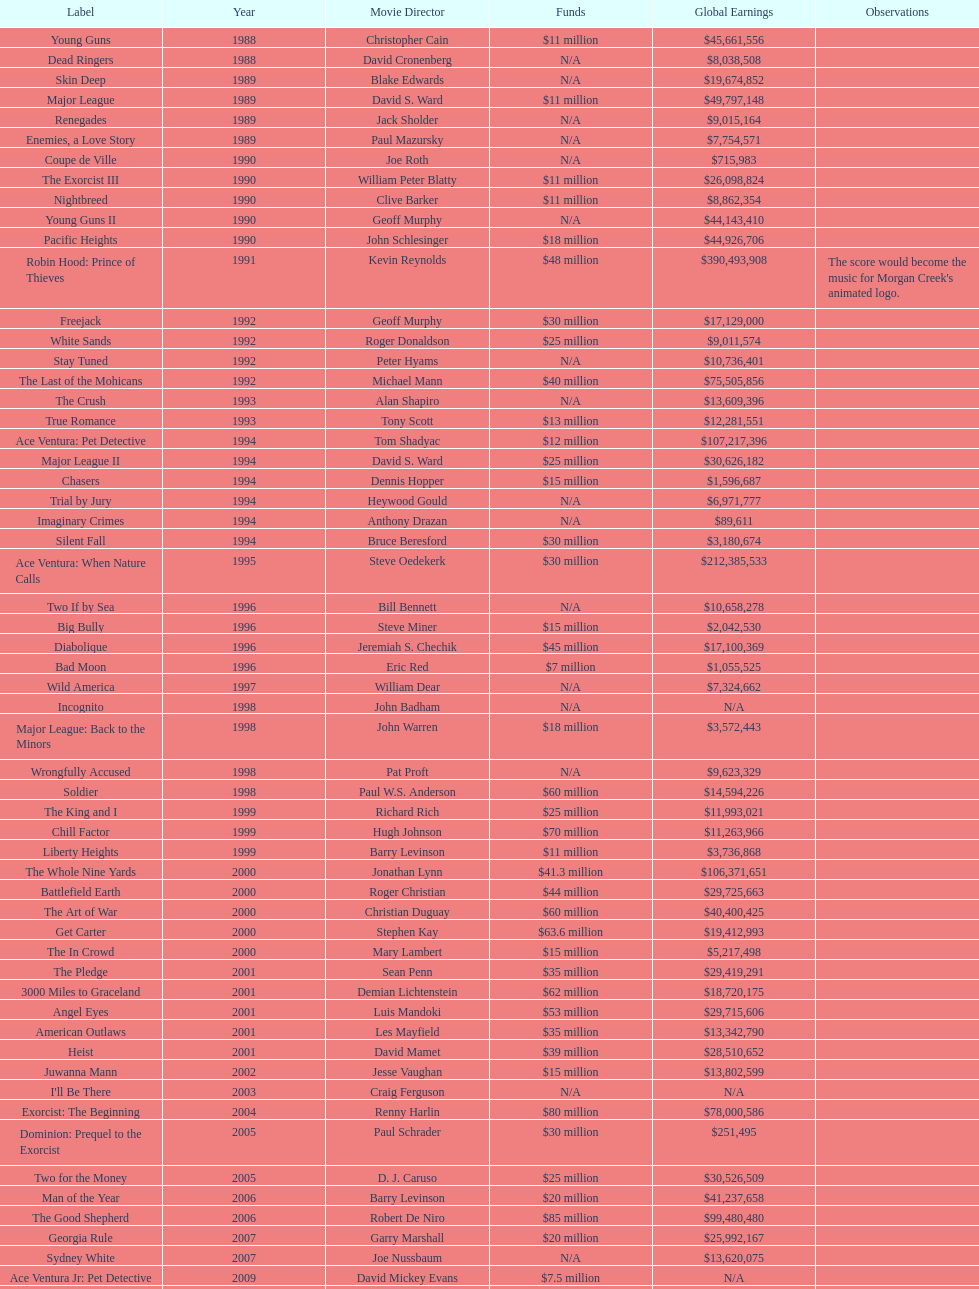Which morgan creek film grossed the most money prior to 1994? Robin Hood: Prince of Thieves. 